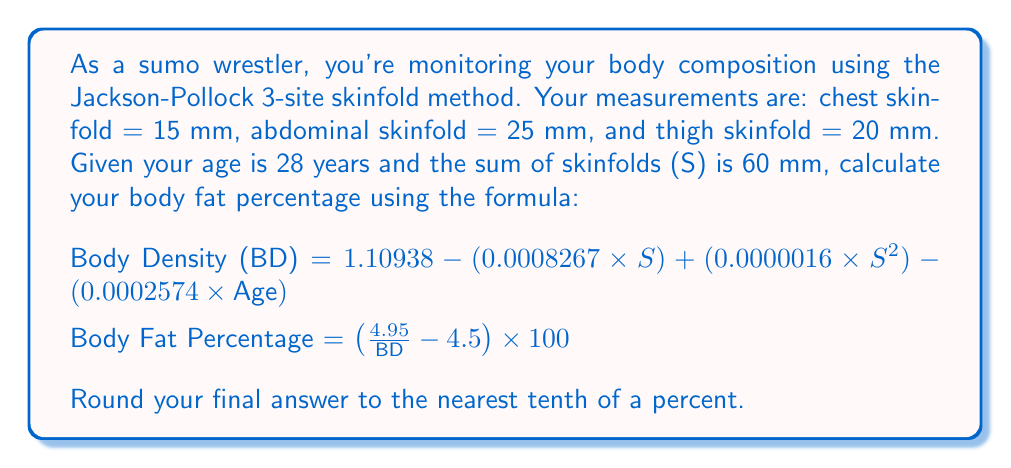Help me with this question. Let's solve this problem step by step:

1) First, we need to calculate the Body Density (BD) using the given formula:

   BD = $1.10938 - (0.0008267 \times S) + (0.0000016 \times S^2) - (0.0002574 \times \text{Age})$

   Where:
   S = 60 mm (sum of skinfolds)
   Age = 28 years

2) Let's substitute these values:

   BD = $1.10938 - (0.0008267 \times 60) + (0.0000016 \times 60^2) - (0.0002574 \times 28)$

3) Now, let's calculate each term:
   
   $0.0008267 \times 60 = 0.049602$
   $0.0000016 \times 60^2 = 0.00576$
   $0.0002574 \times 28 = 0.007207$

4) Substituting back:

   BD = $1.10938 - 0.049602 + 0.00576 - 0.007207$
   
   BD = $1.058331$

5) Now that we have the Body Density, we can calculate the Body Fat Percentage:

   Body Fat Percentage = $(\frac{4.95}{\text{BD}} - 4.5) \times 100$

6) Substituting our BD value:

   Body Fat Percentage = $(\frac{4.95}{1.058331} - 4.5) \times 100$

7) Calculating:
   
   $\frac{4.95}{1.058331} = 4.677269$
   $4.677269 - 4.5 = 0.177269$
   $0.177269 \times 100 = 17.7269$

8) Rounding to the nearest tenth:

   Body Fat Percentage = 17.7%
Answer: 17.7% 